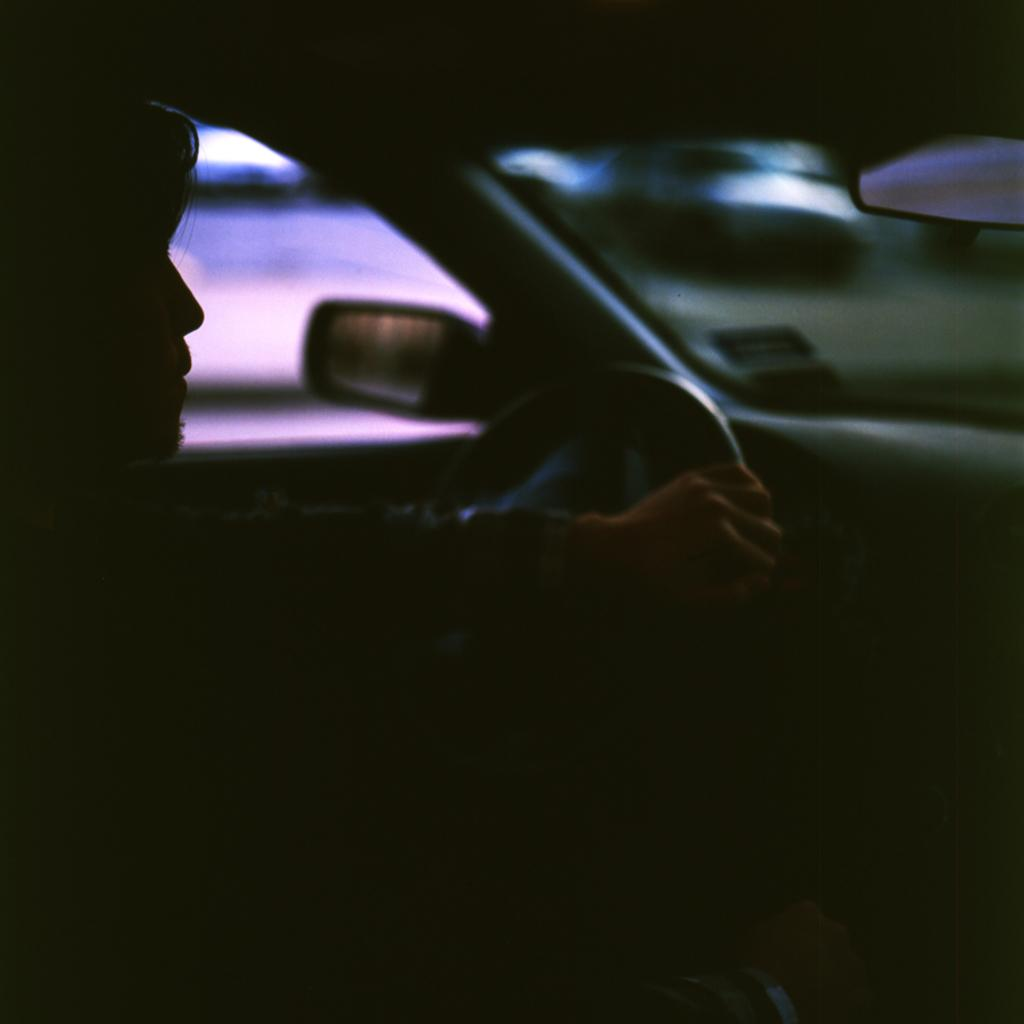What is the main subject of the image? There is a man in the image. What is the man doing in the image? The man is driving a car. What is the man holding while driving the car? The man is holding a steering wheel. What mirrors are visible in the image? A side mirror and a rear mirror are visible in the image. How would you describe the background of the image? The background of the image is blurry. How many servants are visible in the image? There are no servants present in the image. What type of gun can be seen in the image? There is no gun present in the image. 